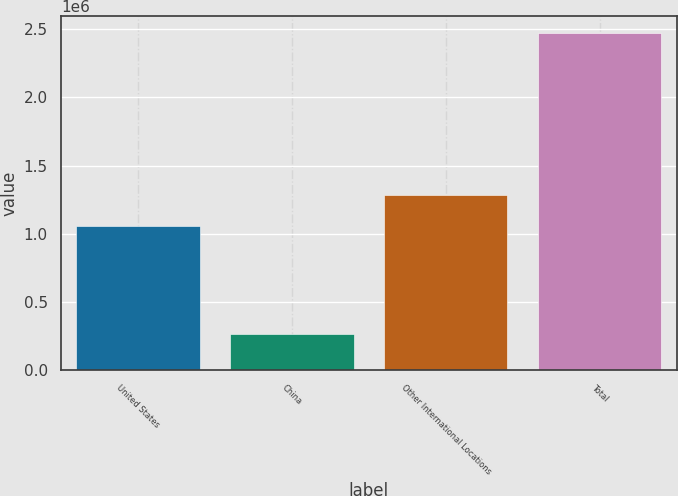Convert chart to OTSL. <chart><loc_0><loc_0><loc_500><loc_500><bar_chart><fcel>United States<fcel>China<fcel>Other International Locations<fcel>Total<nl><fcel>1.05997e+06<fcel>264972<fcel>1.28062e+06<fcel>2.47143e+06<nl></chart> 